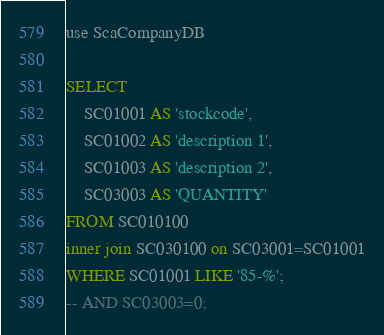<code> <loc_0><loc_0><loc_500><loc_500><_SQL_>use ScaCompanyDB

SELECT
	SC01001 AS 'stockcode',
	SC01002 AS 'description 1',
	SC01003 AS 'description 2',
	SC03003 AS 'QUANTITY'
FROM SC010100
inner join SC030100 on SC03001=SC01001
WHERE SC01001 LIKE '85-%';
-- AND SC03003=0;

</code> 